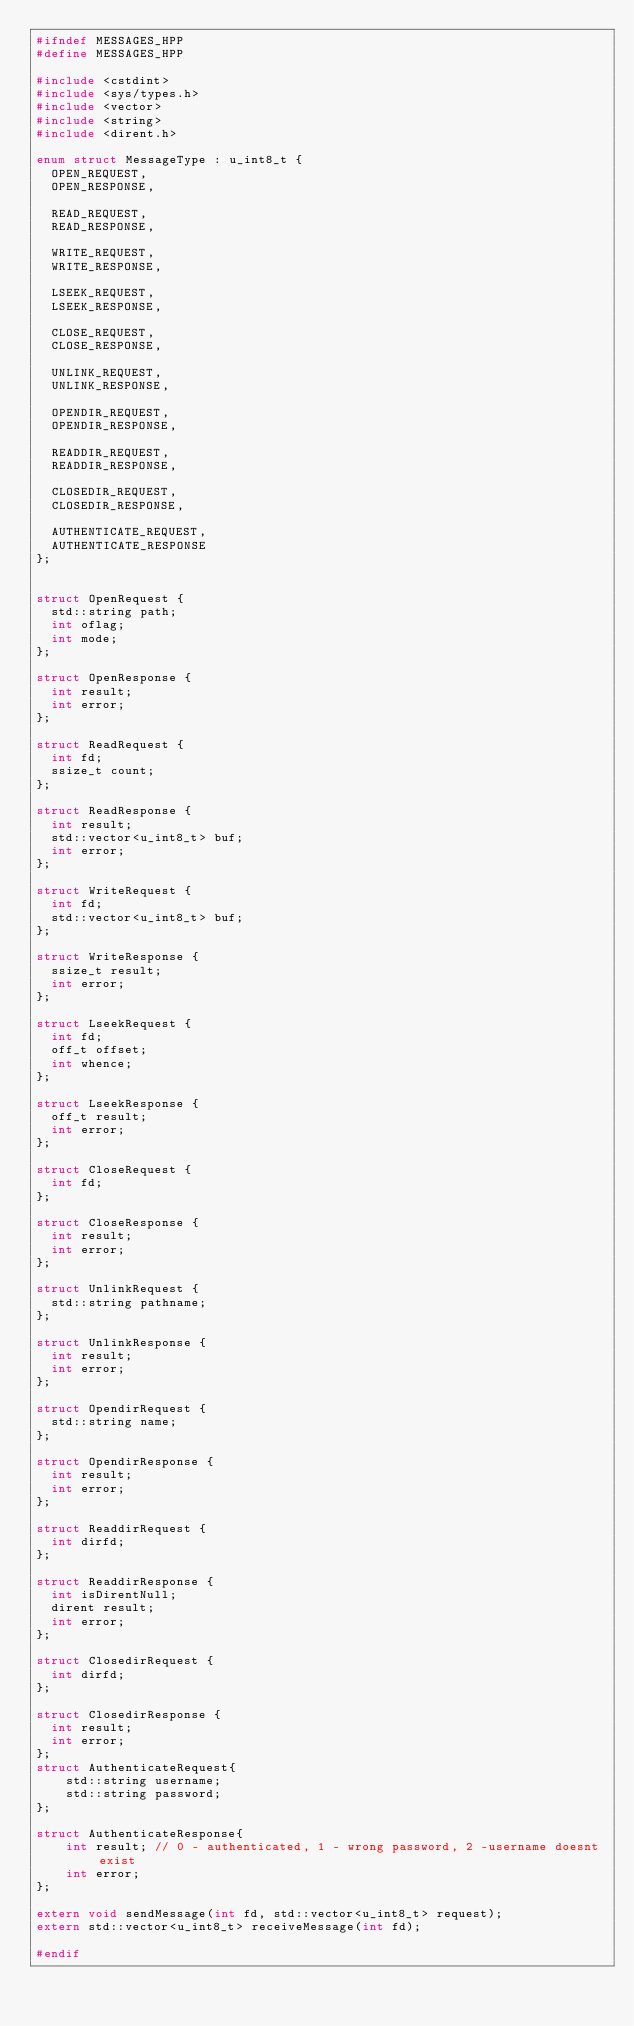<code> <loc_0><loc_0><loc_500><loc_500><_C++_>#ifndef MESSAGES_HPP
#define MESSAGES_HPP

#include <cstdint>
#include <sys/types.h>
#include <vector>
#include <string>
#include <dirent.h>

enum struct MessageType : u_int8_t {
  OPEN_REQUEST,
  OPEN_RESPONSE,

  READ_REQUEST,
  READ_RESPONSE,

  WRITE_REQUEST,
  WRITE_RESPONSE,

  LSEEK_REQUEST,
  LSEEK_RESPONSE,

  CLOSE_REQUEST,
  CLOSE_RESPONSE,

  UNLINK_REQUEST,
  UNLINK_RESPONSE,

  OPENDIR_REQUEST,
  OPENDIR_RESPONSE,

  READDIR_REQUEST,
  READDIR_RESPONSE,

  CLOSEDIR_REQUEST,
  CLOSEDIR_RESPONSE,

  AUTHENTICATE_REQUEST,
  AUTHENTICATE_RESPONSE
};


struct OpenRequest {
  std::string path;
  int oflag;
  int mode;
};

struct OpenResponse {
  int result;
  int error;
};

struct ReadRequest {
  int fd;
  ssize_t count;
};

struct ReadResponse {
  int result;
  std::vector<u_int8_t> buf;
  int error;
};

struct WriteRequest {
  int fd;
  std::vector<u_int8_t> buf;
};

struct WriteResponse {
  ssize_t result;
  int error;
};

struct LseekRequest {
  int fd;
  off_t offset;
  int whence;
};

struct LseekResponse {
  off_t result;
  int error;
};

struct CloseRequest {
  int fd;
};

struct CloseResponse {
  int result;
  int error;
};

struct UnlinkRequest {
  std::string pathname;
};

struct UnlinkResponse {
  int result;
  int error;
};

struct OpendirRequest {
  std::string name;
};

struct OpendirResponse {
  int result;
  int error;
};

struct ReaddirRequest {
  int dirfd;
};

struct ReaddirResponse {
  int isDirentNull;
  dirent result;
  int error;
};

struct ClosedirRequest {
  int dirfd;
};

struct ClosedirResponse {
  int result;
  int error;
};
struct AuthenticateRequest{
    std::string username;
    std::string password;
};

struct AuthenticateResponse{
    int result; // 0 - authenticated, 1 - wrong password, 2 -username doesnt exist
    int error;
};

extern void sendMessage(int fd, std::vector<u_int8_t> request);
extern std::vector<u_int8_t> receiveMessage(int fd);

#endif
</code> 